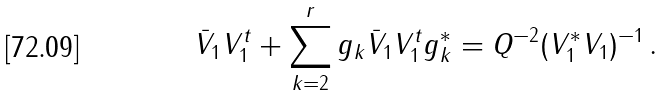<formula> <loc_0><loc_0><loc_500><loc_500>\bar { V } _ { 1 } V _ { 1 } ^ { t } + \sum _ { k = 2 } ^ { r } g _ { k } \bar { V } _ { 1 } V _ { 1 } ^ { t } g _ { k } ^ { * } = Q ^ { - 2 } ( V _ { 1 } ^ { * } V _ { 1 } ) ^ { - 1 } \, .</formula> 